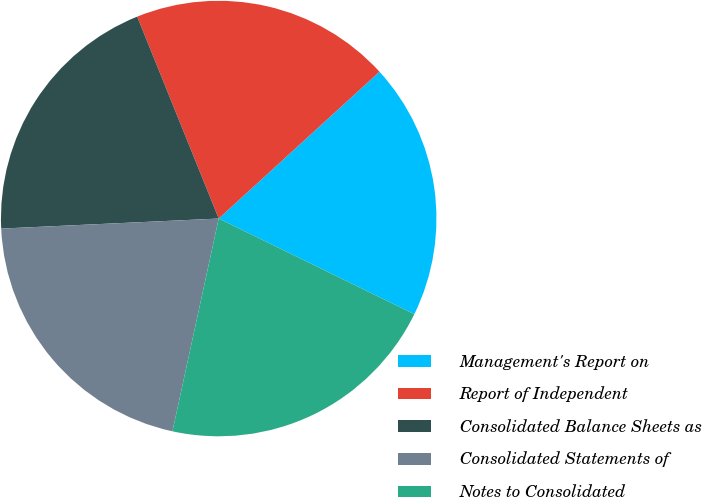Convert chart to OTSL. <chart><loc_0><loc_0><loc_500><loc_500><pie_chart><fcel>Management's Report on<fcel>Report of Independent<fcel>Consolidated Balance Sheets as<fcel>Consolidated Statements of<fcel>Notes to Consolidated<nl><fcel>19.02%<fcel>19.33%<fcel>19.63%<fcel>20.86%<fcel>21.17%<nl></chart> 